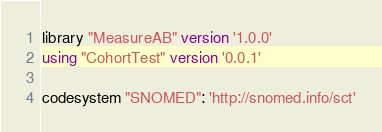<code> <loc_0><loc_0><loc_500><loc_500><_SQL_>library "MeasureAB" version '1.0.0'
using "CohortTest" version '0.0.1'

codesystem "SNOMED": 'http://snomed.info/sct'</code> 